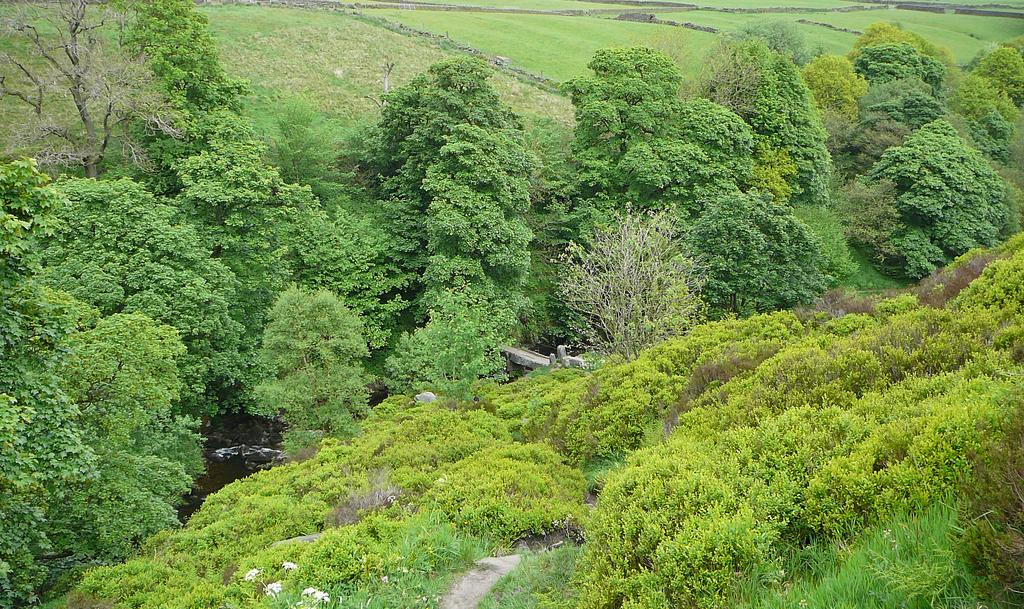What type of vegetation can be seen in the image? There are trees in the image. What can be seen in the background of the image? There is grass and plants visible in the background of the image. How does the health of the trees in the image compare to the health of the plants in the image? There is no information provided about the health of the trees or plants in the image, so it cannot be determined. 